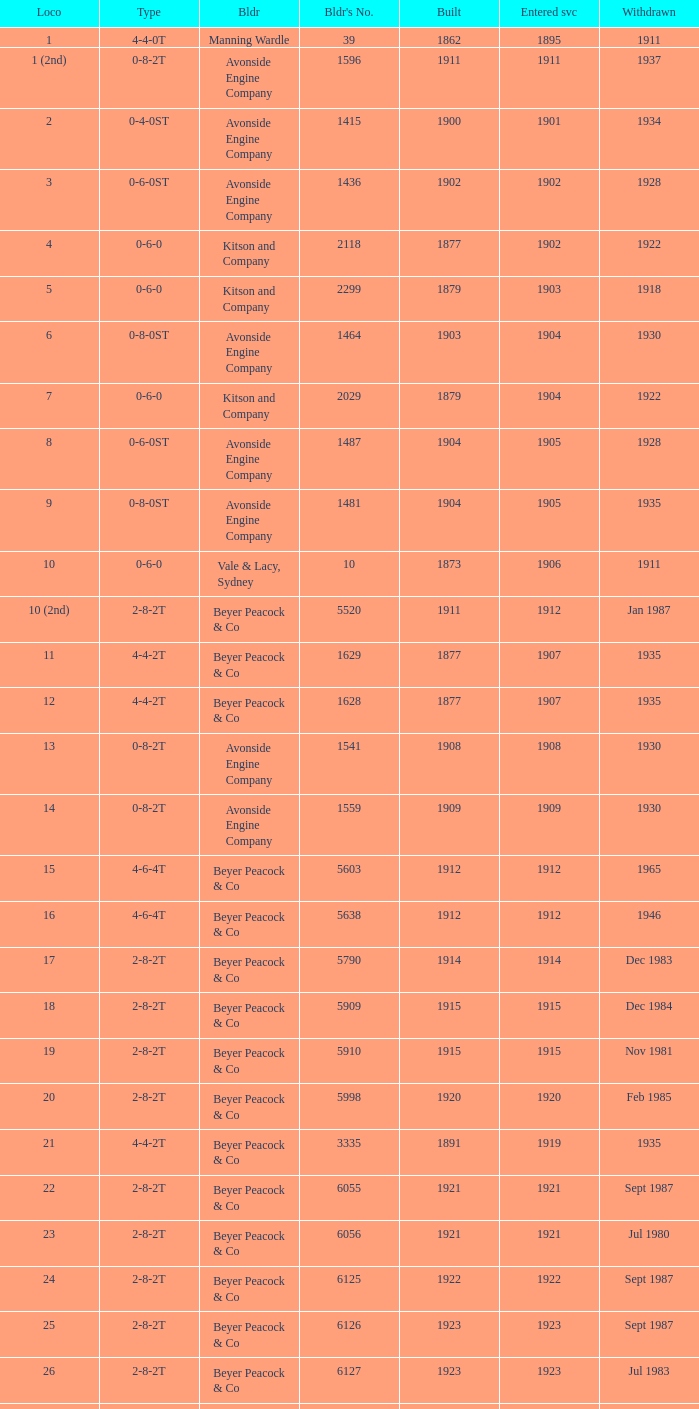Which locomotive had a 2-8-2t type, entered service year prior to 1915, and which was built after 1911? 17.0. 